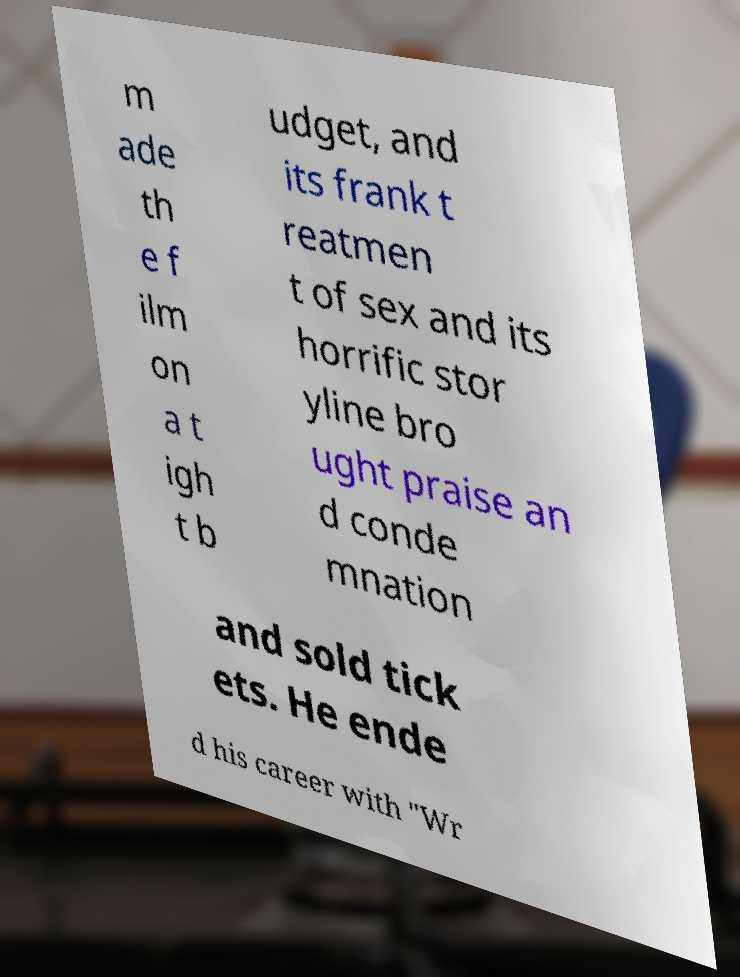For documentation purposes, I need the text within this image transcribed. Could you provide that? m ade th e f ilm on a t igh t b udget, and its frank t reatmen t of sex and its horrific stor yline bro ught praise an d conde mnation and sold tick ets. He ende d his career with "Wr 